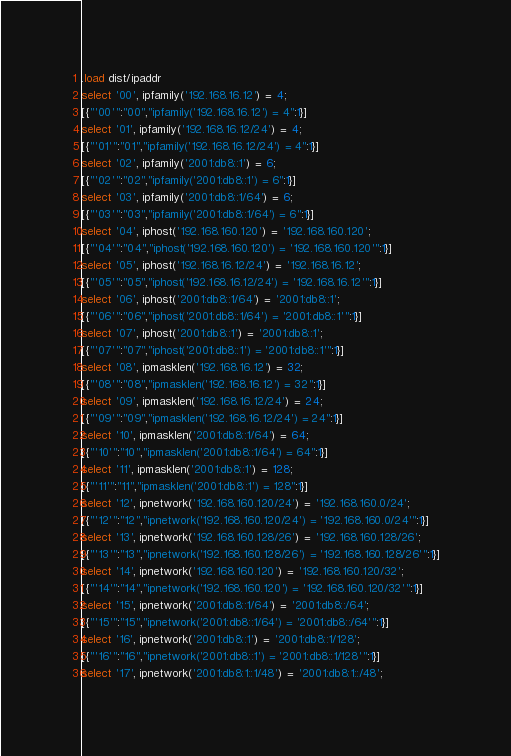<code> <loc_0><loc_0><loc_500><loc_500><_SQL_>.load dist/ipaddr
select '00', ipfamily('192.168.16.12') = 4;
[{"'00'":"00","ipfamily('192.168.16.12') = 4":1}]
select '01', ipfamily('192.168.16.12/24') = 4;
[{"'01'":"01","ipfamily('192.168.16.12/24') = 4":1}]
select '02', ipfamily('2001:db8::1') = 6;
[{"'02'":"02","ipfamily('2001:db8::1') = 6":1}]
select '03', ipfamily('2001:db8::1/64') = 6;
[{"'03'":"03","ipfamily('2001:db8::1/64') = 6":1}]
select '04', iphost('192.168.160.120') = '192.168.160.120';
[{"'04'":"04","iphost('192.168.160.120') = '192.168.160.120'":1}]
select '05', iphost('192.168.16.12/24') = '192.168.16.12';
[{"'05'":"05","iphost('192.168.16.12/24') = '192.168.16.12'":1}]
select '06', iphost('2001:db8::1/64') = '2001:db8::1';
[{"'06'":"06","iphost('2001:db8::1/64') = '2001:db8::1'":1}]
select '07', iphost('2001:db8::1') = '2001:db8::1';
[{"'07'":"07","iphost('2001:db8::1') = '2001:db8::1'":1}]
select '08', ipmasklen('192.168.16.12') = 32;
[{"'08'":"08","ipmasklen('192.168.16.12') = 32":1}]
select '09', ipmasklen('192.168.16.12/24') = 24;
[{"'09'":"09","ipmasklen('192.168.16.12/24') = 24":1}]
select '10', ipmasklen('2001:db8::1/64') = 64;
[{"'10'":"10","ipmasklen('2001:db8::1/64') = 64":1}]
select '11', ipmasklen('2001:db8::1') = 128;
[{"'11'":"11","ipmasklen('2001:db8::1') = 128":1}]
select '12', ipnetwork('192.168.160.120/24') = '192.168.160.0/24';
[{"'12'":"12","ipnetwork('192.168.160.120/24') = '192.168.160.0/24'":1}]
select '13', ipnetwork('192.168.160.128/26') = '192.168.160.128/26';
[{"'13'":"13","ipnetwork('192.168.160.128/26') = '192.168.160.128/26'":1}]
select '14', ipnetwork('192.168.160.120') = '192.168.160.120/32';
[{"'14'":"14","ipnetwork('192.168.160.120') = '192.168.160.120/32'":1}]
select '15', ipnetwork('2001:db8::1/64') = '2001:db8::/64';
[{"'15'":"15","ipnetwork('2001:db8::1/64') = '2001:db8::/64'":1}]
select '16', ipnetwork('2001:db8::1') = '2001:db8::1/128';
[{"'16'":"16","ipnetwork('2001:db8::1') = '2001:db8::1/128'":1}]
select '17', ipnetwork('2001:db8:1::1/48') = '2001:db8:1::/48';</code> 